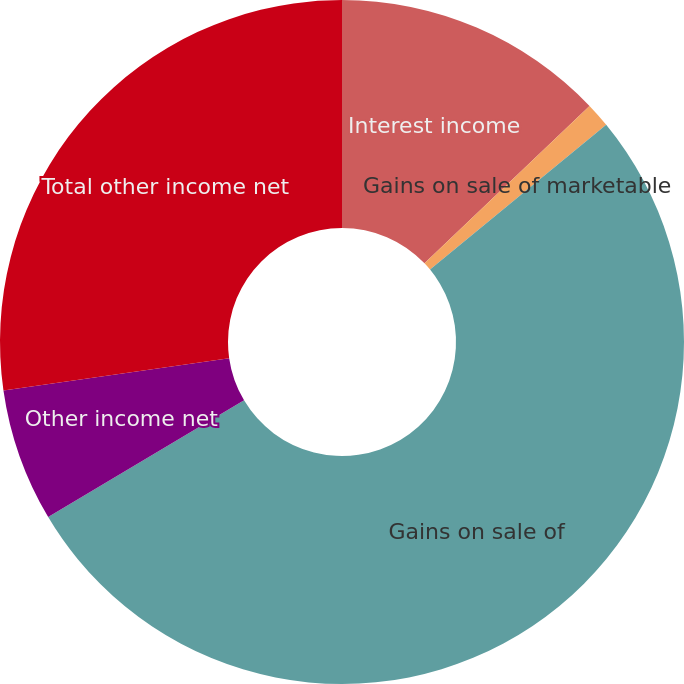<chart> <loc_0><loc_0><loc_500><loc_500><pie_chart><fcel>Interest income<fcel>Gains on sale of marketable<fcel>Gains on sale of<fcel>Other income net<fcel>Total other income net<nl><fcel>12.88%<fcel>1.17%<fcel>52.4%<fcel>6.29%<fcel>27.26%<nl></chart> 